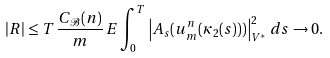Convert formula to latex. <formula><loc_0><loc_0><loc_500><loc_500>| R | \leq T \, \frac { C _ { \mathcal { B } } ( n ) } { m } \, E \int _ { 0 } ^ { T } \left | A _ { s } ( u ^ { n } _ { m } ( \kappa _ { 2 } ( s ) ) ) \right | _ { V ^ { \ast } } ^ { 2 } \, d s \to 0 .</formula> 